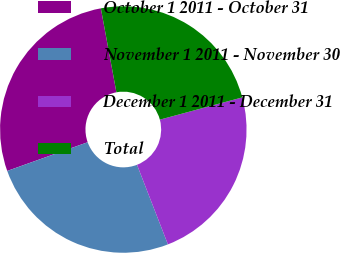Convert chart to OTSL. <chart><loc_0><loc_0><loc_500><loc_500><pie_chart><fcel>October 1 2011 - October 31<fcel>November 1 2011 - November 30<fcel>December 1 2011 - December 31<fcel>Total<nl><fcel>27.54%<fcel>25.44%<fcel>23.3%<fcel>23.72%<nl></chart> 